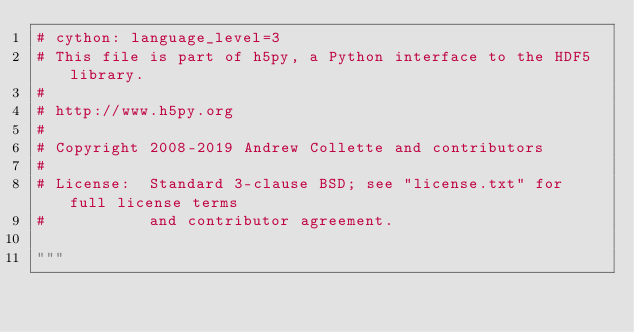Convert code to text. <code><loc_0><loc_0><loc_500><loc_500><_Cython_># cython: language_level=3
# This file is part of h5py, a Python interface to the HDF5 library.
#
# http://www.h5py.org
#
# Copyright 2008-2019 Andrew Collette and contributors
#
# License:  Standard 3-clause BSD; see "license.txt" for full license terms
#           and contributor agreement.

"""</code> 